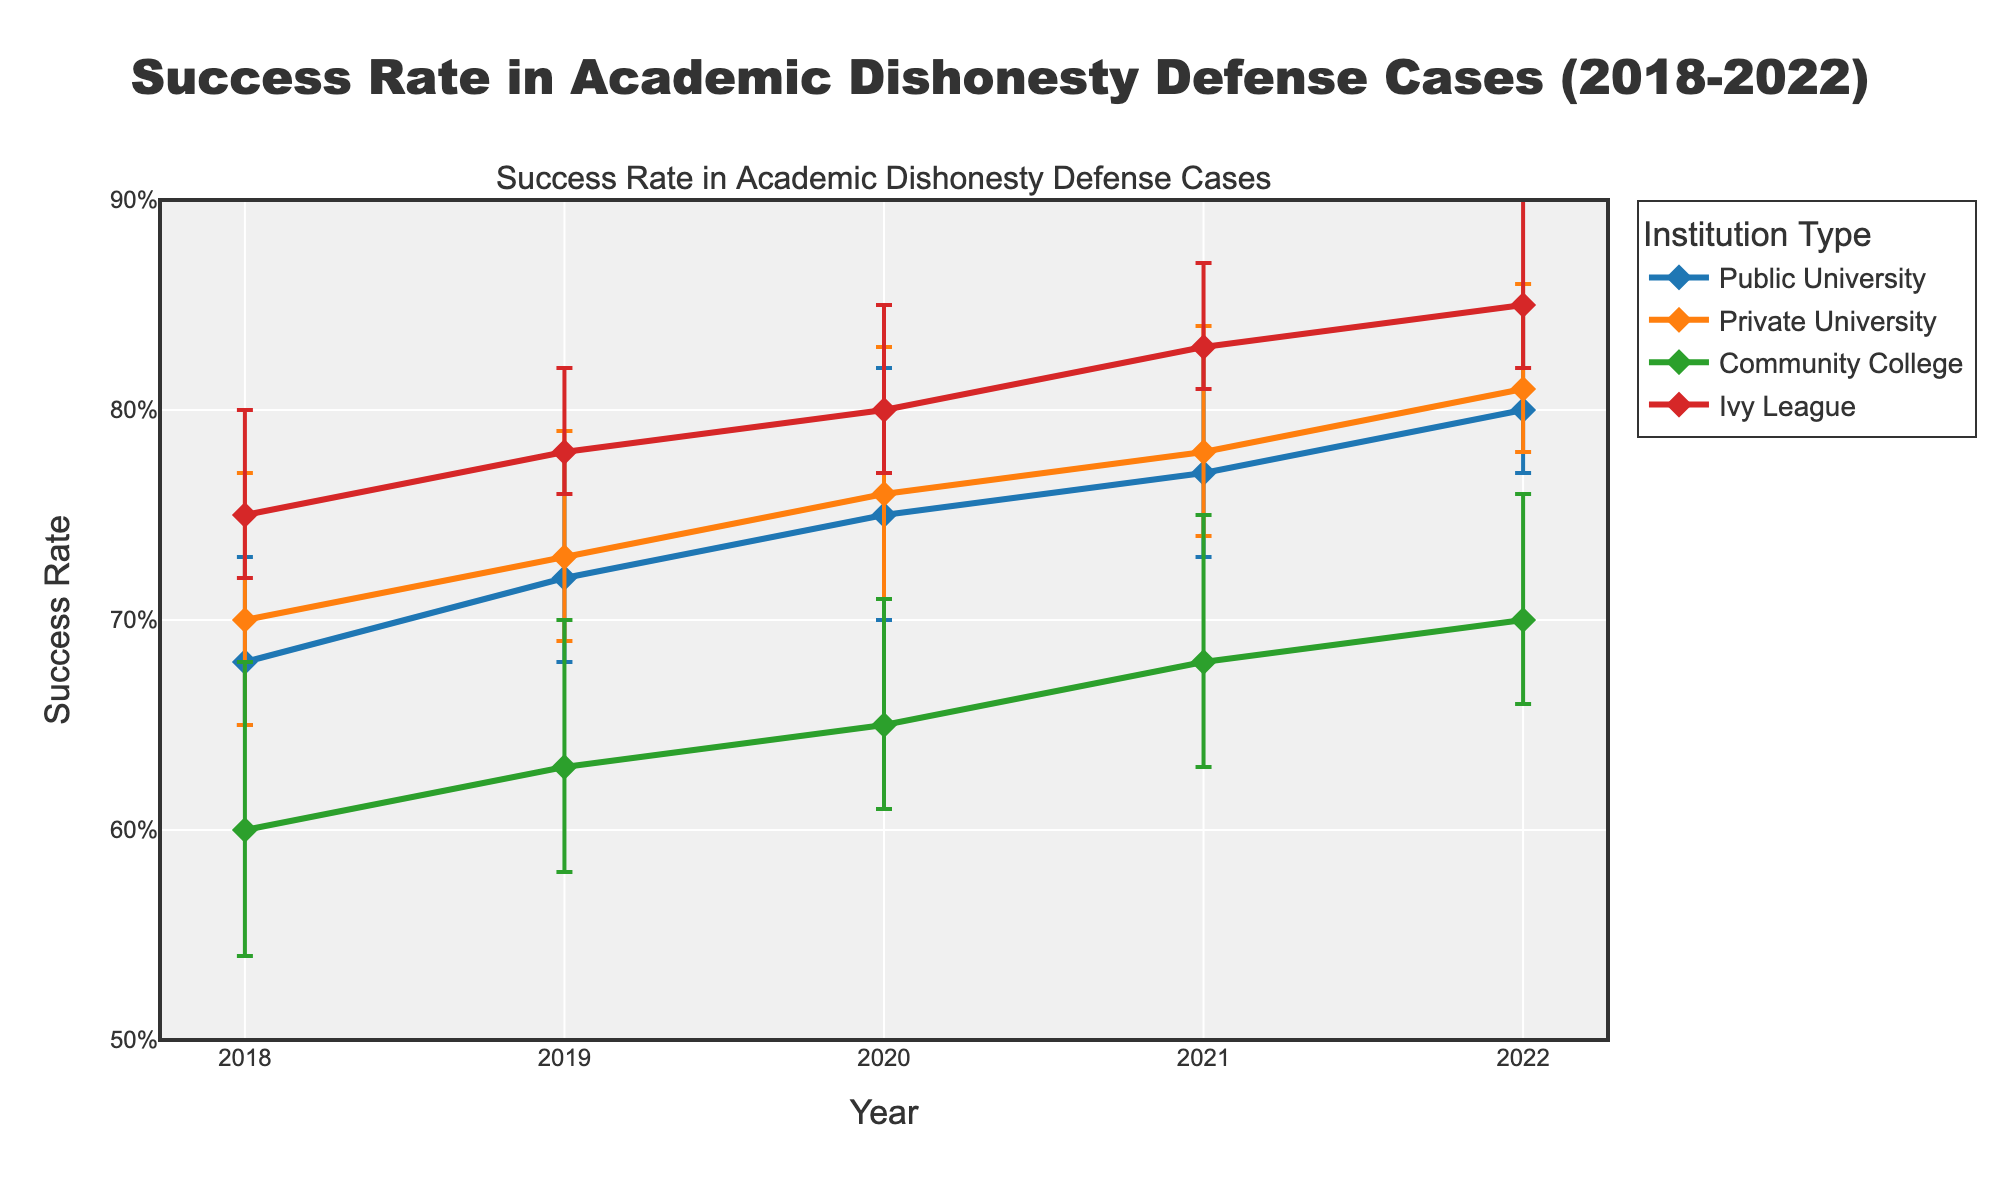What is the title of the figure? The title of the figure is typically located at the top and summarizes what the plot is about. In this case, it reads "Success Rate in Academic Dishonesty Defense Cases (2018-2022)"
Answer: Success Rate in Academic Dishonesty Defense Cases (2018-2022) What is the success rate for Public University cases in 2020? Look at the line and marker labeled "Public University" and refer to the point corresponding to the year 2020. The y-axis value tells us the success rate.
Answer: 0.75 Which institution type has the highest success rate in 2022? Compare the y-values of the different lines at the point corresponding to the year 2022. The "Ivy League" line has the highest y-value for that year.
Answer: Ivy League How many types of institutions are shown in the figure? Look at the legend or the different lines on the plot. Each line represents a different institution type. Their names are also listed.
Answer: 4 What is the range of success rates for the Ivy League in 2019? Refer to the error bars for the Ivy League in the year 2019. The lower error bar is 0.78 - 0.02 = 0.76, and the upper error bar is 0.78 + 0.04 = 0.82.
Answer: 0.76 to 0.82 Has the success rate for Community Colleges increased or decreased from 2018 to 2022? Look at the starting and ending points of the Community College line between 2018 and 2022. The line shows an upward trend.
Answer: Increased What is the overall trend of success rates for Public Universities from 2018 to 2022? Observe the Public University line from 2018 to 2022. The line shows a consistent upward trend.
Answer: Increasing In which year did Private Universities have the highest variability in success rates? Check the length of error bars for Private Universities over different years. The longest error bar indicates the highest variability, visible in 2018.
Answer: 2018 Which institution type shows the least change in success rate from 2018 to 2022? For each institution type, weigh the steepness or flatness of the corresponding line. Community Colleges have the shallowest slope.
Answer: Community College Comparing 2020, which institution has a higher success rate: Public University or Private University? Compare the y-values of the markers for Public University and Private University in the year 2020. Private University has a higher y-value.
Answer: Private University 